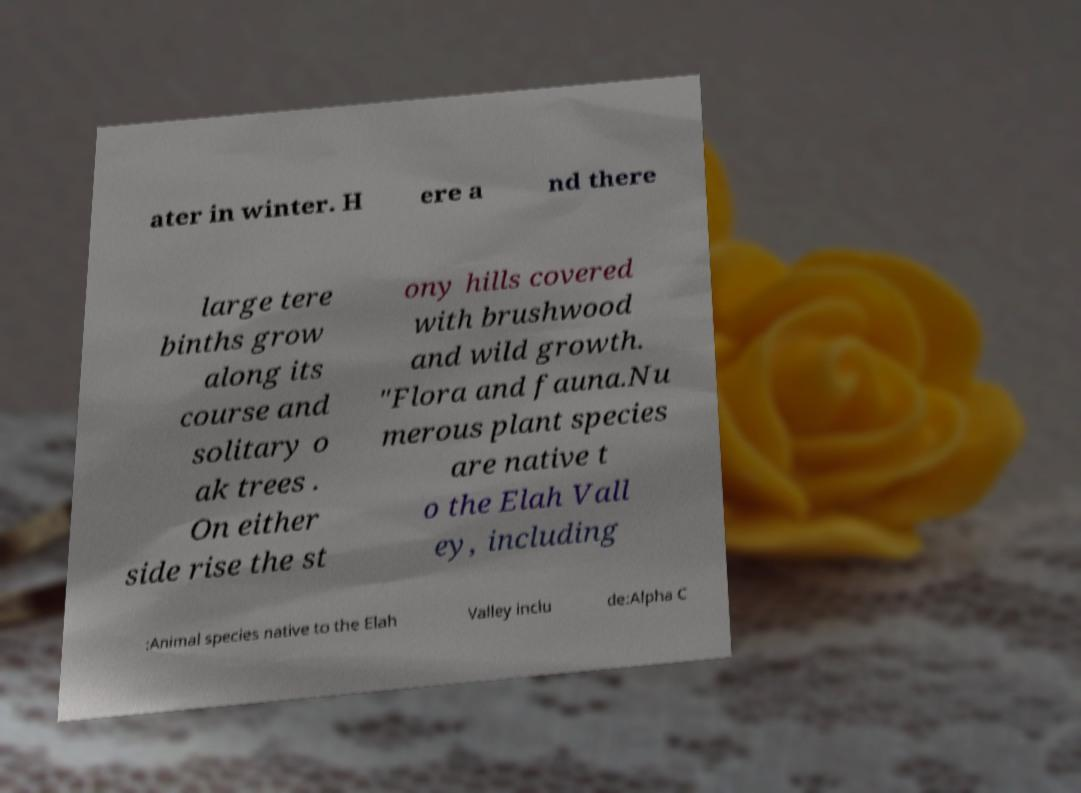Please read and relay the text visible in this image. What does it say? ater in winter. H ere a nd there large tere binths grow along its course and solitary o ak trees . On either side rise the st ony hills covered with brushwood and wild growth. "Flora and fauna.Nu merous plant species are native t o the Elah Vall ey, including :Animal species native to the Elah Valley inclu de:Alpha C 